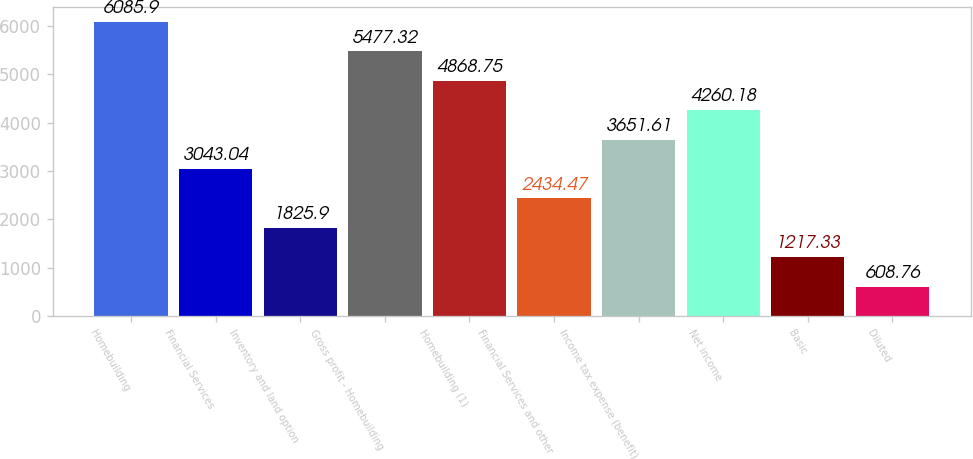<chart> <loc_0><loc_0><loc_500><loc_500><bar_chart><fcel>Homebuilding<fcel>Financial Services<fcel>Inventory and land option<fcel>Gross profit - Homebuilding<fcel>Homebuilding (1)<fcel>Financial Services and other<fcel>Income tax expense (benefit)<fcel>Net income<fcel>Basic<fcel>Diluted<nl><fcel>6085.9<fcel>3043.04<fcel>1825.9<fcel>5477.32<fcel>4868.75<fcel>2434.47<fcel>3651.61<fcel>4260.18<fcel>1217.33<fcel>608.76<nl></chart> 